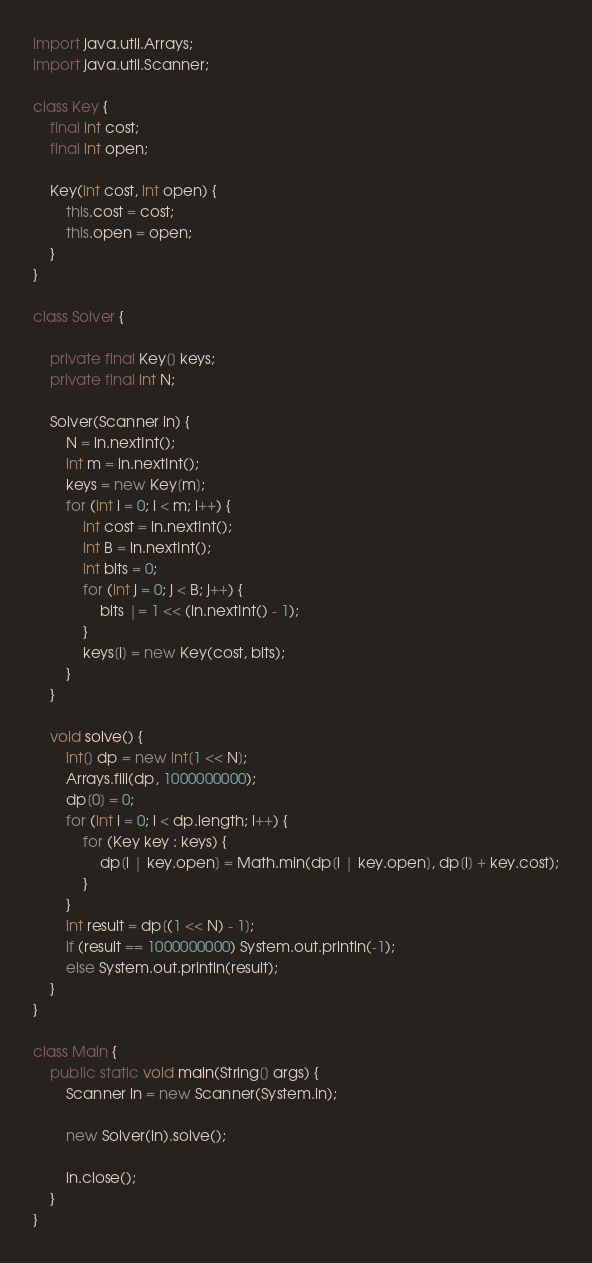<code> <loc_0><loc_0><loc_500><loc_500><_Java_>import java.util.Arrays;
import java.util.Scanner;

class Key {
    final int cost;
    final int open;

    Key(int cost, int open) {
        this.cost = cost;
        this.open = open;
    }
}

class Solver {

    private final Key[] keys;
    private final int N;

    Solver(Scanner in) {
        N = in.nextInt();
        int m = in.nextInt();
        keys = new Key[m];
        for (int i = 0; i < m; i++) {
            int cost = in.nextInt();
            int B = in.nextInt();
            int bits = 0;
            for (int j = 0; j < B; j++) {
                bits |= 1 << (in.nextInt() - 1);
            }
            keys[i] = new Key(cost, bits);
        }
    }

    void solve() {
        int[] dp = new int[1 << N];
        Arrays.fill(dp, 1000000000);
        dp[0] = 0;
        for (int i = 0; i < dp.length; i++) {
            for (Key key : keys) {
                dp[i | key.open] = Math.min(dp[i | key.open], dp[i] + key.cost);
            }
        }
        int result = dp[(1 << N) - 1];
        if (result == 1000000000) System.out.println(-1);
        else System.out.println(result);
    }
}

class Main {
    public static void main(String[] args) {
        Scanner in = new Scanner(System.in);

        new Solver(in).solve();

        in.close();
    }
}</code> 